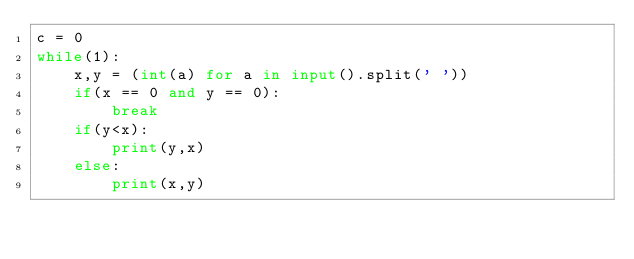Convert code to text. <code><loc_0><loc_0><loc_500><loc_500><_Python_>c = 0
while(1):
    x,y = (int(a) for a in input().split(' '))
    if(x == 0 and y == 0):
        break
    if(y<x):
        print(y,x)
    else:
        print(x,y)
</code> 